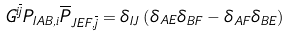<formula> <loc_0><loc_0><loc_500><loc_500>G ^ { i \overline { j } } P _ { I A B , i } \overline { P } _ { J E F , \overline { j } } = \delta _ { I J } \left ( \delta _ { A E } \delta _ { B F } - \delta _ { A F } \delta _ { B E } \right )</formula> 